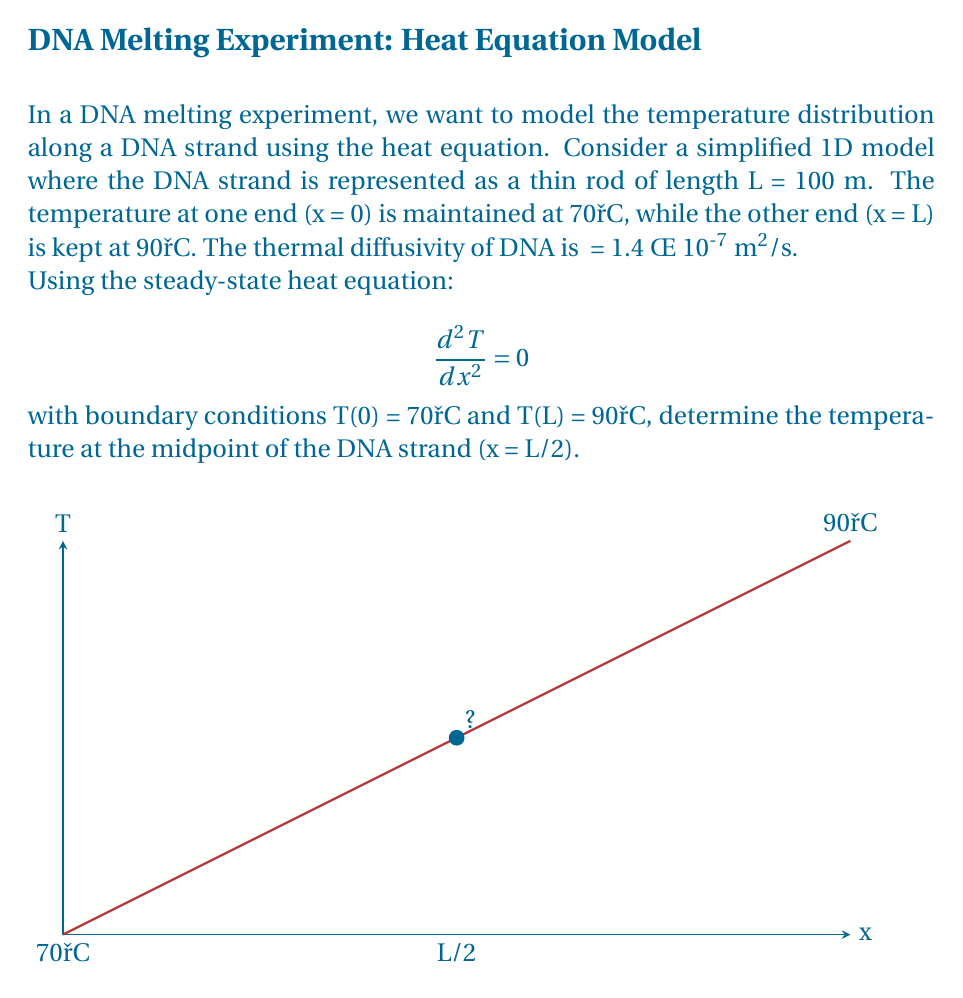Could you help me with this problem? To solve this problem, we'll follow these steps:

1) The general solution to the steady-state heat equation is:

   $$T(x) = Ax + B$$

   where A and B are constants we need to determine.

2) Apply the boundary conditions:
   At x = 0: T(0) = 70°C
   $$70 = A(0) + B$$
   $$B = 70$$

   At x = L: T(L) = 90°C
   $$90 = A(100 × 10^{-6}) + 70$$

3) Solve for A:
   $$A = \frac{90 - 70}{100 × 10^{-6}} = 2 × 10^5 °C/m$$

4) Now we have the complete solution:
   $$T(x) = (2 × 10^5)x + 70$$

5) To find the temperature at the midpoint (x = L/2):
   $$T(L/2) = (2 × 10^5)(50 × 10^{-6}) + 70$$
   $$T(L/2) = 10 + 70 = 80°C$$

Therefore, the temperature at the midpoint of the DNA strand is 80°C.
Answer: 80°C 